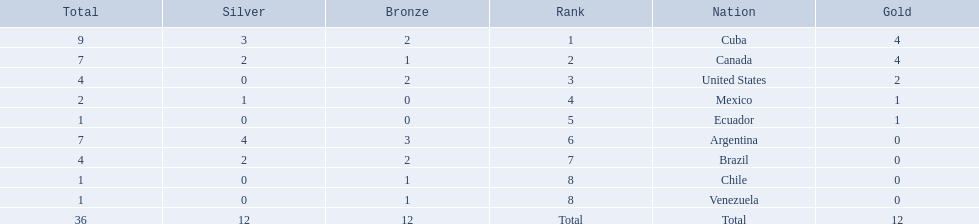Which countries have won gold medals? Cuba, Canada, United States, Mexico, Ecuador. Of these countries, which ones have never won silver or bronze medals? United States, Ecuador. Of the two nations listed previously, which one has only won a gold medal? Ecuador. Which countries won medals at the 2011 pan american games for the canoeing event? Cuba, Canada, United States, Mexico, Ecuador, Argentina, Brazil, Chile, Venezuela. Which of these countries won bronze medals? Cuba, Canada, United States, Argentina, Brazil, Chile, Venezuela. Of these countries, which won the most bronze medals? Argentina. 